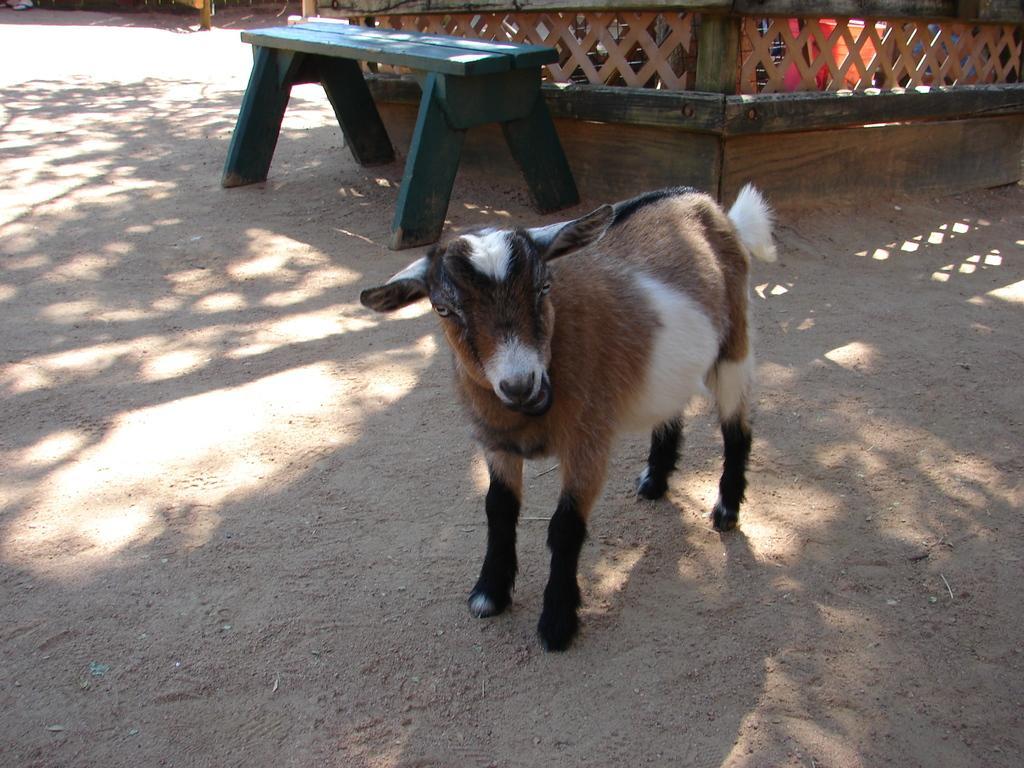Can you describe this image briefly? In this image In the middle there is a goat it is staring at something. In the background there is a bench and wooden house. 